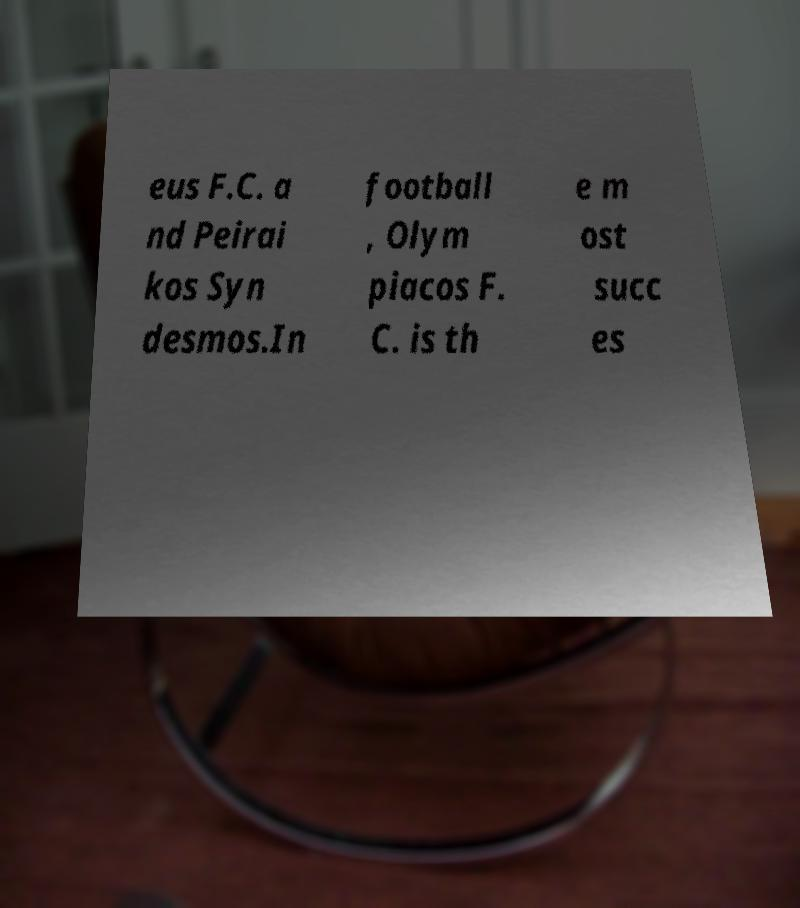Please read and relay the text visible in this image. What does it say? eus F.C. a nd Peirai kos Syn desmos.In football , Olym piacos F. C. is th e m ost succ es 